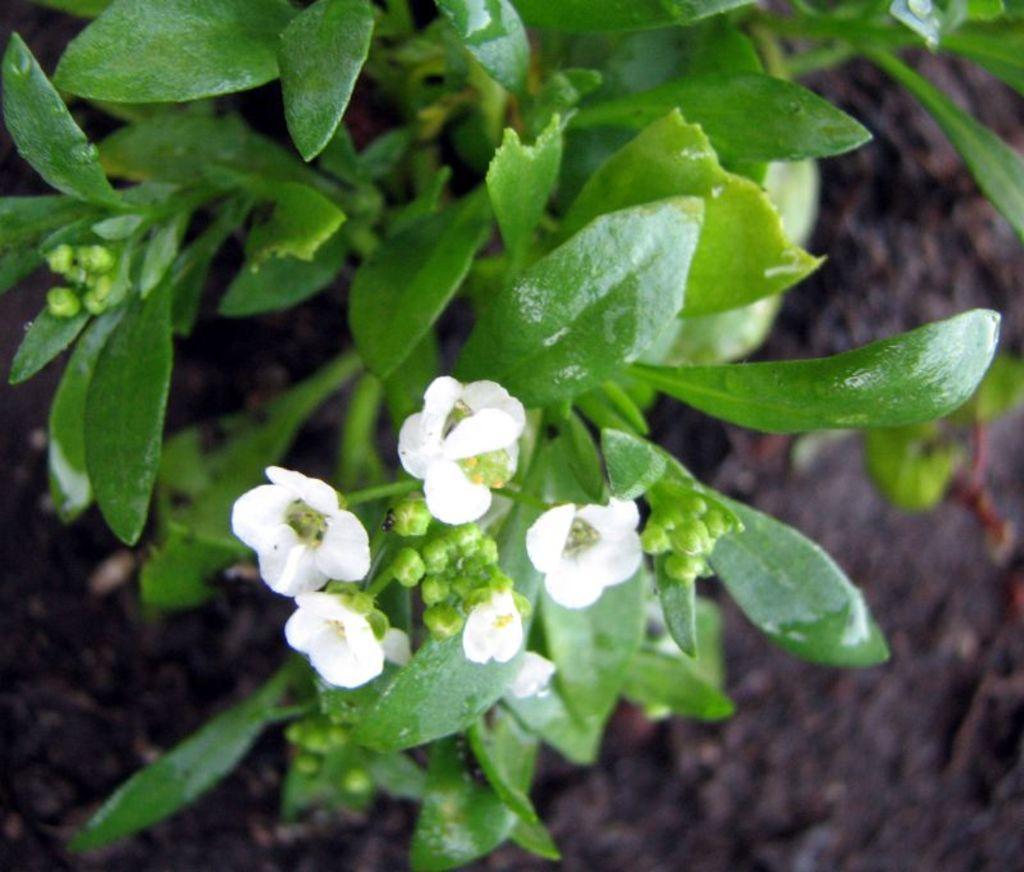Describe this image in one or two sentences. In the picture we can see some plants with white color flowers to it and under the plants we can see a muddy path. 